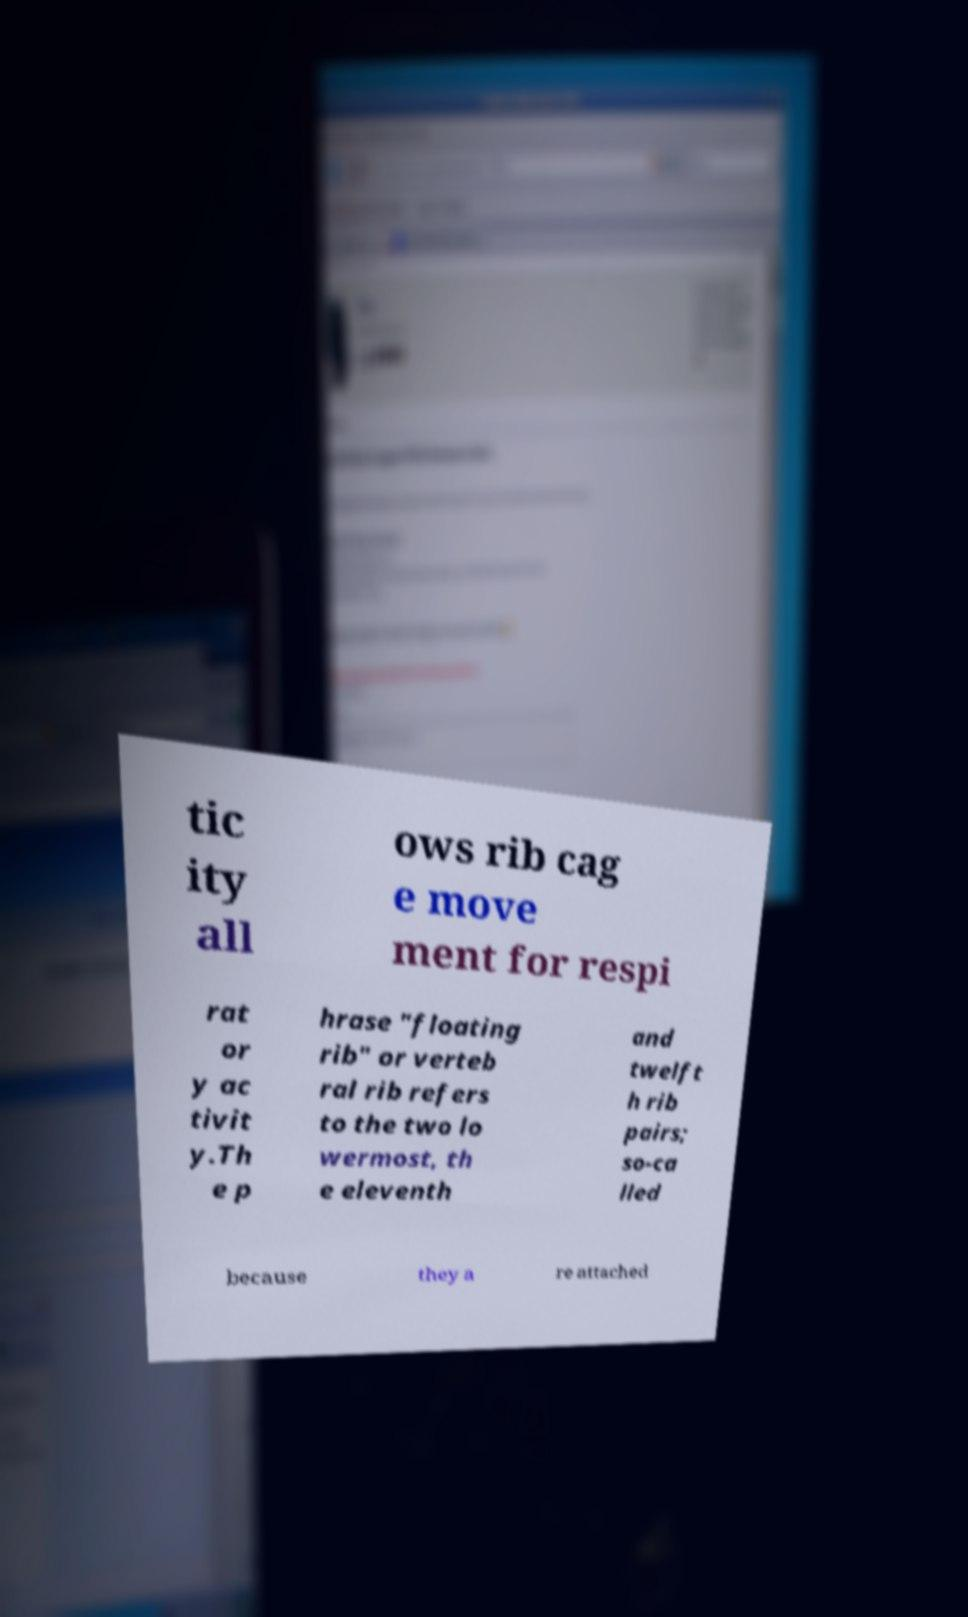Please identify and transcribe the text found in this image. tic ity all ows rib cag e move ment for respi rat or y ac tivit y.Th e p hrase "floating rib" or verteb ral rib refers to the two lo wermost, th e eleventh and twelft h rib pairs; so-ca lled because they a re attached 